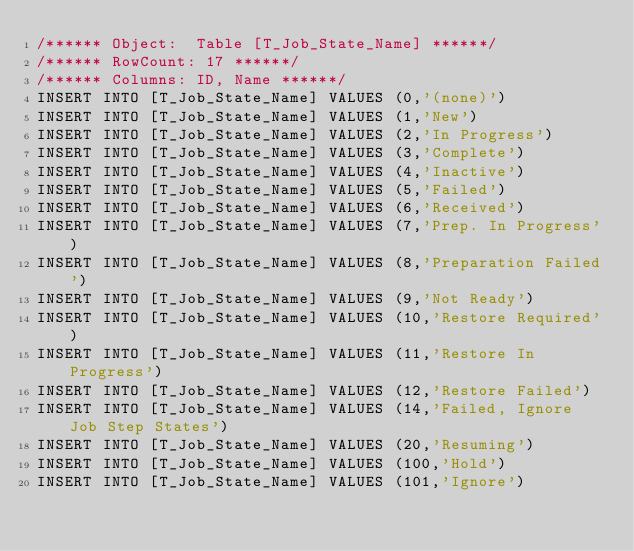<code> <loc_0><loc_0><loc_500><loc_500><_SQL_>/****** Object:  Table [T_Job_State_Name] ******/
/****** RowCount: 17 ******/
/****** Columns: ID, Name ******/
INSERT INTO [T_Job_State_Name] VALUES (0,'(none)')
INSERT INTO [T_Job_State_Name] VALUES (1,'New')
INSERT INTO [T_Job_State_Name] VALUES (2,'In Progress')
INSERT INTO [T_Job_State_Name] VALUES (3,'Complete')
INSERT INTO [T_Job_State_Name] VALUES (4,'Inactive')
INSERT INTO [T_Job_State_Name] VALUES (5,'Failed')
INSERT INTO [T_Job_State_Name] VALUES (6,'Received')
INSERT INTO [T_Job_State_Name] VALUES (7,'Prep. In Progress')
INSERT INTO [T_Job_State_Name] VALUES (8,'Preparation Failed')
INSERT INTO [T_Job_State_Name] VALUES (9,'Not Ready')
INSERT INTO [T_Job_State_Name] VALUES (10,'Restore Required')
INSERT INTO [T_Job_State_Name] VALUES (11,'Restore In Progress')
INSERT INTO [T_Job_State_Name] VALUES (12,'Restore Failed')
INSERT INTO [T_Job_State_Name] VALUES (14,'Failed, Ignore Job Step States')
INSERT INTO [T_Job_State_Name] VALUES (20,'Resuming')
INSERT INTO [T_Job_State_Name] VALUES (100,'Hold')
INSERT INTO [T_Job_State_Name] VALUES (101,'Ignore')
</code> 